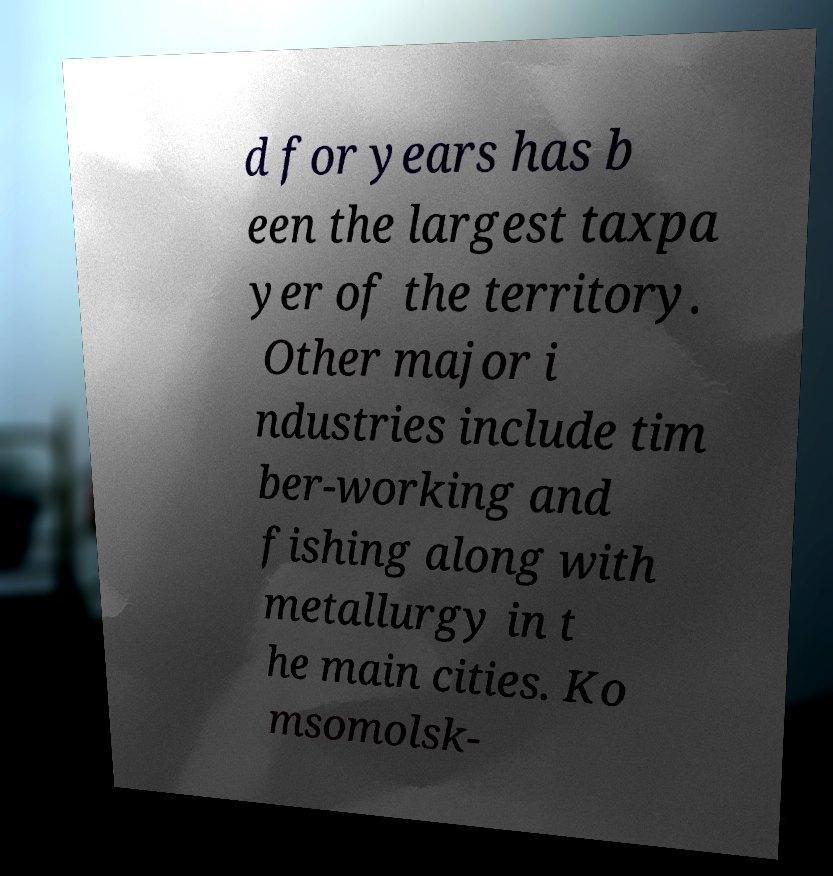There's text embedded in this image that I need extracted. Can you transcribe it verbatim? d for years has b een the largest taxpa yer of the territory. Other major i ndustries include tim ber-working and fishing along with metallurgy in t he main cities. Ko msomolsk- 